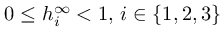Convert formula to latex. <formula><loc_0><loc_0><loc_500><loc_500>0 \leq h _ { i } ^ { \infty } < 1 , \, i \in \{ 1 , 2 , 3 \}</formula> 